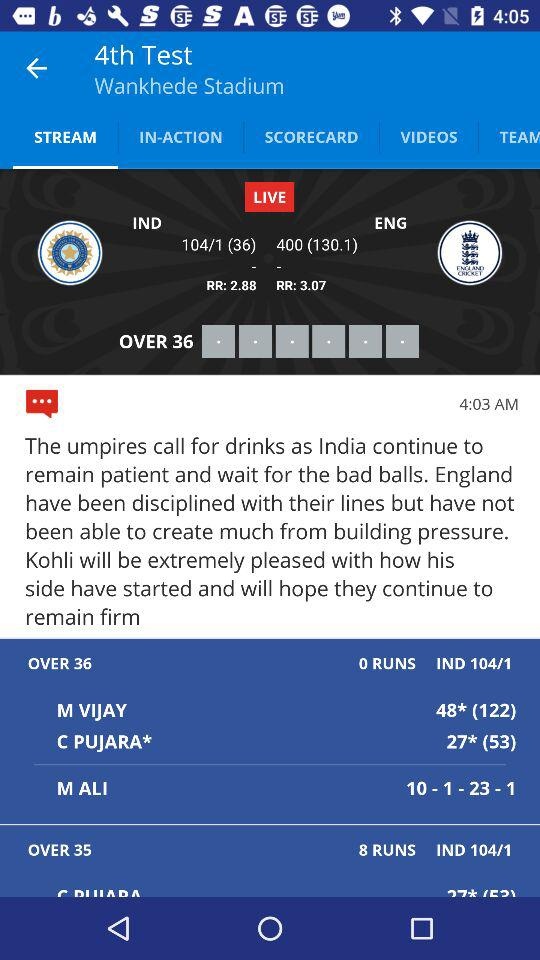How many wickets does India have? Based on the image, India has lost 1 wicket in their innings as the score reads 104/1, where '1' represents the number of wickets fallen. 